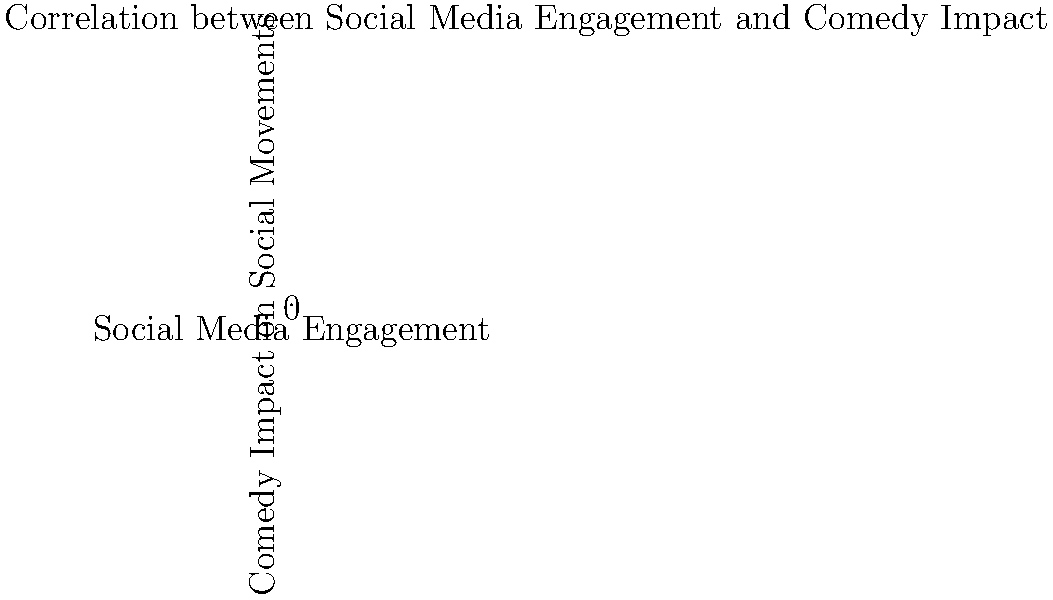Based on the scatter plot, what type of correlation appears to exist between social media engagement and the impact of comedic activism on social movements? To determine the type of correlation between social media engagement and the impact of comedic activism on social movements, we need to analyze the pattern of the data points in the scatter plot:

1. Observe the overall trend: As we move from left to right (increasing social media engagement), the data points generally move upward (increasing comedy impact).

2. Assess the consistency: The upward trend is relatively consistent, with most points following this pattern.

3. Evaluate the strength: The points form a fairly tight cluster around an imaginary line running from the bottom-left to the top-right of the graph, indicating a strong relationship.

4. Consider the direction: The trend is positive, meaning as one variable increases, the other tends to increase as well.

5. Look for linearity: The relationship appears to be approximately linear, with points clustered around a straight line.

Given these observations, we can conclude that there is a strong positive linear correlation between social media engagement and the impact of comedic activism on social movements.
Answer: Strong positive linear correlation 